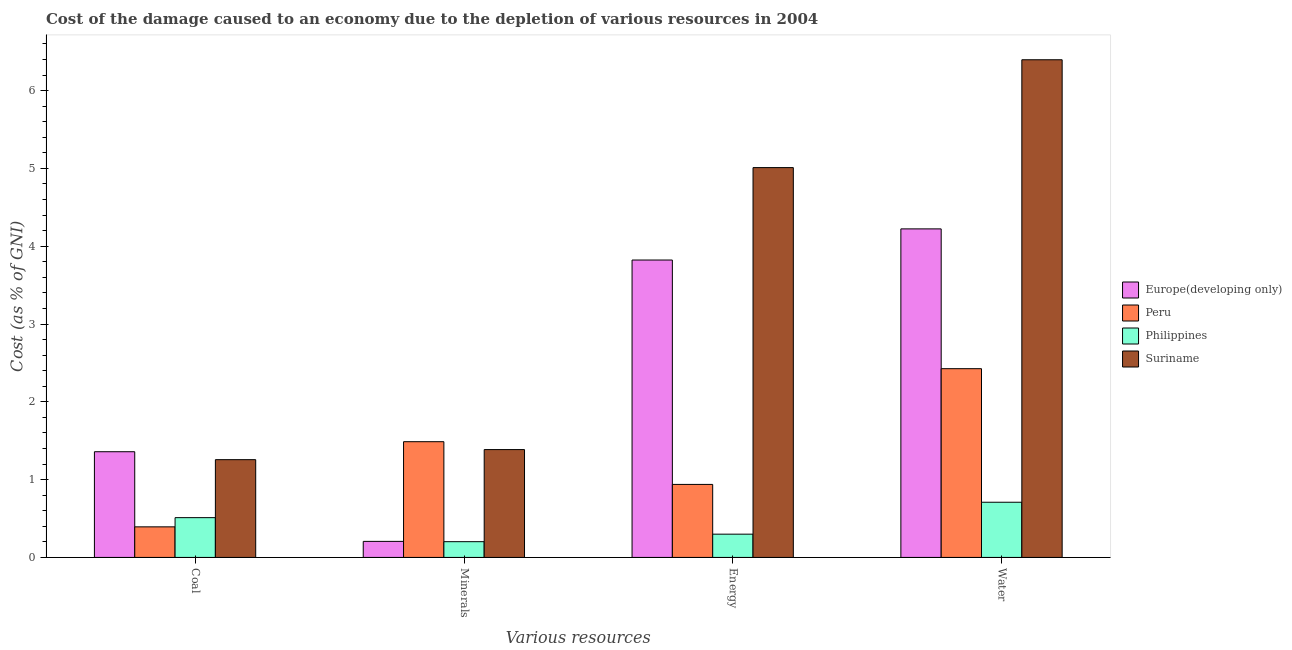How many different coloured bars are there?
Your answer should be compact. 4. How many groups of bars are there?
Provide a succinct answer. 4. Are the number of bars on each tick of the X-axis equal?
Your response must be concise. Yes. How many bars are there on the 3rd tick from the right?
Ensure brevity in your answer.  4. What is the label of the 3rd group of bars from the left?
Your answer should be compact. Energy. What is the cost of damage due to depletion of water in Philippines?
Your response must be concise. 0.71. Across all countries, what is the maximum cost of damage due to depletion of energy?
Keep it short and to the point. 5.01. Across all countries, what is the minimum cost of damage due to depletion of minerals?
Keep it short and to the point. 0.2. In which country was the cost of damage due to depletion of water maximum?
Offer a very short reply. Suriname. In which country was the cost of damage due to depletion of water minimum?
Your answer should be compact. Philippines. What is the total cost of damage due to depletion of water in the graph?
Offer a terse response. 13.75. What is the difference between the cost of damage due to depletion of water in Peru and that in Philippines?
Your answer should be very brief. 1.72. What is the difference between the cost of damage due to depletion of minerals in Philippines and the cost of damage due to depletion of water in Europe(developing only)?
Offer a terse response. -4.02. What is the average cost of damage due to depletion of coal per country?
Make the answer very short. 0.88. What is the difference between the cost of damage due to depletion of energy and cost of damage due to depletion of coal in Europe(developing only)?
Keep it short and to the point. 2.46. What is the ratio of the cost of damage due to depletion of coal in Philippines to that in Peru?
Ensure brevity in your answer.  1.3. Is the cost of damage due to depletion of water in Suriname less than that in Europe(developing only)?
Offer a very short reply. No. What is the difference between the highest and the second highest cost of damage due to depletion of water?
Provide a short and direct response. 2.17. What is the difference between the highest and the lowest cost of damage due to depletion of coal?
Keep it short and to the point. 0.97. In how many countries, is the cost of damage due to depletion of coal greater than the average cost of damage due to depletion of coal taken over all countries?
Your answer should be compact. 2. Is the sum of the cost of damage due to depletion of coal in Suriname and Europe(developing only) greater than the maximum cost of damage due to depletion of water across all countries?
Offer a terse response. No. What does the 1st bar from the left in Minerals represents?
Your answer should be compact. Europe(developing only). Is it the case that in every country, the sum of the cost of damage due to depletion of coal and cost of damage due to depletion of minerals is greater than the cost of damage due to depletion of energy?
Your answer should be compact. No. How many countries are there in the graph?
Keep it short and to the point. 4. What is the difference between two consecutive major ticks on the Y-axis?
Your response must be concise. 1. Are the values on the major ticks of Y-axis written in scientific E-notation?
Provide a succinct answer. No. Does the graph contain any zero values?
Provide a short and direct response. No. Does the graph contain grids?
Ensure brevity in your answer.  No. Where does the legend appear in the graph?
Offer a terse response. Center right. How many legend labels are there?
Your answer should be very brief. 4. How are the legend labels stacked?
Keep it short and to the point. Vertical. What is the title of the graph?
Offer a terse response. Cost of the damage caused to an economy due to the depletion of various resources in 2004 . What is the label or title of the X-axis?
Provide a short and direct response. Various resources. What is the label or title of the Y-axis?
Offer a terse response. Cost (as % of GNI). What is the Cost (as % of GNI) of Europe(developing only) in Coal?
Offer a terse response. 1.36. What is the Cost (as % of GNI) in Peru in Coal?
Offer a terse response. 0.39. What is the Cost (as % of GNI) of Philippines in Coal?
Your answer should be compact. 0.51. What is the Cost (as % of GNI) in Suriname in Coal?
Your answer should be very brief. 1.26. What is the Cost (as % of GNI) in Europe(developing only) in Minerals?
Offer a terse response. 0.21. What is the Cost (as % of GNI) in Peru in Minerals?
Provide a succinct answer. 1.49. What is the Cost (as % of GNI) of Philippines in Minerals?
Keep it short and to the point. 0.2. What is the Cost (as % of GNI) in Suriname in Minerals?
Make the answer very short. 1.39. What is the Cost (as % of GNI) in Europe(developing only) in Energy?
Provide a short and direct response. 3.82. What is the Cost (as % of GNI) in Peru in Energy?
Provide a succinct answer. 0.94. What is the Cost (as % of GNI) of Philippines in Energy?
Keep it short and to the point. 0.3. What is the Cost (as % of GNI) of Suriname in Energy?
Offer a very short reply. 5.01. What is the Cost (as % of GNI) in Europe(developing only) in Water?
Provide a short and direct response. 4.22. What is the Cost (as % of GNI) of Peru in Water?
Make the answer very short. 2.43. What is the Cost (as % of GNI) of Philippines in Water?
Provide a succinct answer. 0.71. What is the Cost (as % of GNI) of Suriname in Water?
Provide a succinct answer. 6.4. Across all Various resources, what is the maximum Cost (as % of GNI) in Europe(developing only)?
Offer a terse response. 4.22. Across all Various resources, what is the maximum Cost (as % of GNI) of Peru?
Your answer should be very brief. 2.43. Across all Various resources, what is the maximum Cost (as % of GNI) of Philippines?
Your response must be concise. 0.71. Across all Various resources, what is the maximum Cost (as % of GNI) in Suriname?
Ensure brevity in your answer.  6.4. Across all Various resources, what is the minimum Cost (as % of GNI) of Europe(developing only)?
Provide a short and direct response. 0.21. Across all Various resources, what is the minimum Cost (as % of GNI) in Peru?
Your answer should be compact. 0.39. Across all Various resources, what is the minimum Cost (as % of GNI) of Philippines?
Offer a very short reply. 0.2. Across all Various resources, what is the minimum Cost (as % of GNI) in Suriname?
Keep it short and to the point. 1.26. What is the total Cost (as % of GNI) of Europe(developing only) in the graph?
Your response must be concise. 9.61. What is the total Cost (as % of GNI) of Peru in the graph?
Give a very brief answer. 5.24. What is the total Cost (as % of GNI) of Philippines in the graph?
Offer a terse response. 1.72. What is the total Cost (as % of GNI) of Suriname in the graph?
Ensure brevity in your answer.  14.05. What is the difference between the Cost (as % of GNI) in Europe(developing only) in Coal and that in Minerals?
Give a very brief answer. 1.15. What is the difference between the Cost (as % of GNI) of Peru in Coal and that in Minerals?
Provide a short and direct response. -1.09. What is the difference between the Cost (as % of GNI) of Philippines in Coal and that in Minerals?
Provide a succinct answer. 0.31. What is the difference between the Cost (as % of GNI) of Suriname in Coal and that in Minerals?
Give a very brief answer. -0.13. What is the difference between the Cost (as % of GNI) of Europe(developing only) in Coal and that in Energy?
Offer a terse response. -2.46. What is the difference between the Cost (as % of GNI) of Peru in Coal and that in Energy?
Give a very brief answer. -0.55. What is the difference between the Cost (as % of GNI) in Philippines in Coal and that in Energy?
Keep it short and to the point. 0.21. What is the difference between the Cost (as % of GNI) in Suriname in Coal and that in Energy?
Offer a terse response. -3.75. What is the difference between the Cost (as % of GNI) of Europe(developing only) in Coal and that in Water?
Your answer should be very brief. -2.86. What is the difference between the Cost (as % of GNI) in Peru in Coal and that in Water?
Offer a very short reply. -2.03. What is the difference between the Cost (as % of GNI) of Philippines in Coal and that in Water?
Your response must be concise. -0.2. What is the difference between the Cost (as % of GNI) in Suriname in Coal and that in Water?
Your response must be concise. -5.14. What is the difference between the Cost (as % of GNI) in Europe(developing only) in Minerals and that in Energy?
Ensure brevity in your answer.  -3.62. What is the difference between the Cost (as % of GNI) in Peru in Minerals and that in Energy?
Give a very brief answer. 0.55. What is the difference between the Cost (as % of GNI) of Philippines in Minerals and that in Energy?
Offer a terse response. -0.1. What is the difference between the Cost (as % of GNI) of Suriname in Minerals and that in Energy?
Your response must be concise. -3.62. What is the difference between the Cost (as % of GNI) in Europe(developing only) in Minerals and that in Water?
Your answer should be compact. -4.02. What is the difference between the Cost (as % of GNI) of Peru in Minerals and that in Water?
Ensure brevity in your answer.  -0.94. What is the difference between the Cost (as % of GNI) of Philippines in Minerals and that in Water?
Offer a terse response. -0.51. What is the difference between the Cost (as % of GNI) in Suriname in Minerals and that in Water?
Keep it short and to the point. -5.01. What is the difference between the Cost (as % of GNI) of Europe(developing only) in Energy and that in Water?
Offer a terse response. -0.4. What is the difference between the Cost (as % of GNI) in Peru in Energy and that in Water?
Make the answer very short. -1.49. What is the difference between the Cost (as % of GNI) in Philippines in Energy and that in Water?
Give a very brief answer. -0.41. What is the difference between the Cost (as % of GNI) in Suriname in Energy and that in Water?
Make the answer very short. -1.39. What is the difference between the Cost (as % of GNI) in Europe(developing only) in Coal and the Cost (as % of GNI) in Peru in Minerals?
Make the answer very short. -0.13. What is the difference between the Cost (as % of GNI) of Europe(developing only) in Coal and the Cost (as % of GNI) of Philippines in Minerals?
Provide a short and direct response. 1.16. What is the difference between the Cost (as % of GNI) in Europe(developing only) in Coal and the Cost (as % of GNI) in Suriname in Minerals?
Make the answer very short. -0.03. What is the difference between the Cost (as % of GNI) of Peru in Coal and the Cost (as % of GNI) of Philippines in Minerals?
Give a very brief answer. 0.19. What is the difference between the Cost (as % of GNI) of Peru in Coal and the Cost (as % of GNI) of Suriname in Minerals?
Your answer should be very brief. -0.99. What is the difference between the Cost (as % of GNI) in Philippines in Coal and the Cost (as % of GNI) in Suriname in Minerals?
Make the answer very short. -0.87. What is the difference between the Cost (as % of GNI) in Europe(developing only) in Coal and the Cost (as % of GNI) in Peru in Energy?
Your response must be concise. 0.42. What is the difference between the Cost (as % of GNI) of Europe(developing only) in Coal and the Cost (as % of GNI) of Philippines in Energy?
Your answer should be compact. 1.06. What is the difference between the Cost (as % of GNI) in Europe(developing only) in Coal and the Cost (as % of GNI) in Suriname in Energy?
Your response must be concise. -3.65. What is the difference between the Cost (as % of GNI) of Peru in Coal and the Cost (as % of GNI) of Philippines in Energy?
Ensure brevity in your answer.  0.09. What is the difference between the Cost (as % of GNI) of Peru in Coal and the Cost (as % of GNI) of Suriname in Energy?
Provide a short and direct response. -4.62. What is the difference between the Cost (as % of GNI) in Philippines in Coal and the Cost (as % of GNI) in Suriname in Energy?
Offer a very short reply. -4.5. What is the difference between the Cost (as % of GNI) of Europe(developing only) in Coal and the Cost (as % of GNI) of Peru in Water?
Ensure brevity in your answer.  -1.07. What is the difference between the Cost (as % of GNI) of Europe(developing only) in Coal and the Cost (as % of GNI) of Philippines in Water?
Your answer should be compact. 0.65. What is the difference between the Cost (as % of GNI) in Europe(developing only) in Coal and the Cost (as % of GNI) in Suriname in Water?
Offer a very short reply. -5.04. What is the difference between the Cost (as % of GNI) of Peru in Coal and the Cost (as % of GNI) of Philippines in Water?
Offer a terse response. -0.32. What is the difference between the Cost (as % of GNI) in Peru in Coal and the Cost (as % of GNI) in Suriname in Water?
Provide a short and direct response. -6. What is the difference between the Cost (as % of GNI) in Philippines in Coal and the Cost (as % of GNI) in Suriname in Water?
Your response must be concise. -5.88. What is the difference between the Cost (as % of GNI) of Europe(developing only) in Minerals and the Cost (as % of GNI) of Peru in Energy?
Ensure brevity in your answer.  -0.73. What is the difference between the Cost (as % of GNI) of Europe(developing only) in Minerals and the Cost (as % of GNI) of Philippines in Energy?
Make the answer very short. -0.09. What is the difference between the Cost (as % of GNI) in Europe(developing only) in Minerals and the Cost (as % of GNI) in Suriname in Energy?
Offer a very short reply. -4.8. What is the difference between the Cost (as % of GNI) of Peru in Minerals and the Cost (as % of GNI) of Philippines in Energy?
Provide a succinct answer. 1.19. What is the difference between the Cost (as % of GNI) of Peru in Minerals and the Cost (as % of GNI) of Suriname in Energy?
Ensure brevity in your answer.  -3.52. What is the difference between the Cost (as % of GNI) in Philippines in Minerals and the Cost (as % of GNI) in Suriname in Energy?
Ensure brevity in your answer.  -4.81. What is the difference between the Cost (as % of GNI) of Europe(developing only) in Minerals and the Cost (as % of GNI) of Peru in Water?
Your answer should be compact. -2.22. What is the difference between the Cost (as % of GNI) in Europe(developing only) in Minerals and the Cost (as % of GNI) in Philippines in Water?
Make the answer very short. -0.5. What is the difference between the Cost (as % of GNI) in Europe(developing only) in Minerals and the Cost (as % of GNI) in Suriname in Water?
Give a very brief answer. -6.19. What is the difference between the Cost (as % of GNI) in Peru in Minerals and the Cost (as % of GNI) in Philippines in Water?
Offer a very short reply. 0.78. What is the difference between the Cost (as % of GNI) of Peru in Minerals and the Cost (as % of GNI) of Suriname in Water?
Offer a terse response. -4.91. What is the difference between the Cost (as % of GNI) in Philippines in Minerals and the Cost (as % of GNI) in Suriname in Water?
Give a very brief answer. -6.19. What is the difference between the Cost (as % of GNI) of Europe(developing only) in Energy and the Cost (as % of GNI) of Peru in Water?
Offer a very short reply. 1.4. What is the difference between the Cost (as % of GNI) in Europe(developing only) in Energy and the Cost (as % of GNI) in Philippines in Water?
Offer a terse response. 3.11. What is the difference between the Cost (as % of GNI) in Europe(developing only) in Energy and the Cost (as % of GNI) in Suriname in Water?
Your response must be concise. -2.57. What is the difference between the Cost (as % of GNI) of Peru in Energy and the Cost (as % of GNI) of Philippines in Water?
Give a very brief answer. 0.23. What is the difference between the Cost (as % of GNI) of Peru in Energy and the Cost (as % of GNI) of Suriname in Water?
Make the answer very short. -5.46. What is the difference between the Cost (as % of GNI) of Philippines in Energy and the Cost (as % of GNI) of Suriname in Water?
Offer a very short reply. -6.1. What is the average Cost (as % of GNI) of Europe(developing only) per Various resources?
Offer a very short reply. 2.4. What is the average Cost (as % of GNI) in Peru per Various resources?
Your answer should be very brief. 1.31. What is the average Cost (as % of GNI) in Philippines per Various resources?
Ensure brevity in your answer.  0.43. What is the average Cost (as % of GNI) in Suriname per Various resources?
Provide a succinct answer. 3.51. What is the difference between the Cost (as % of GNI) of Europe(developing only) and Cost (as % of GNI) of Peru in Coal?
Give a very brief answer. 0.97. What is the difference between the Cost (as % of GNI) of Europe(developing only) and Cost (as % of GNI) of Philippines in Coal?
Offer a terse response. 0.85. What is the difference between the Cost (as % of GNI) in Europe(developing only) and Cost (as % of GNI) in Suriname in Coal?
Keep it short and to the point. 0.1. What is the difference between the Cost (as % of GNI) in Peru and Cost (as % of GNI) in Philippines in Coal?
Give a very brief answer. -0.12. What is the difference between the Cost (as % of GNI) of Peru and Cost (as % of GNI) of Suriname in Coal?
Keep it short and to the point. -0.86. What is the difference between the Cost (as % of GNI) of Philippines and Cost (as % of GNI) of Suriname in Coal?
Keep it short and to the point. -0.75. What is the difference between the Cost (as % of GNI) of Europe(developing only) and Cost (as % of GNI) of Peru in Minerals?
Offer a very short reply. -1.28. What is the difference between the Cost (as % of GNI) in Europe(developing only) and Cost (as % of GNI) in Philippines in Minerals?
Your response must be concise. 0. What is the difference between the Cost (as % of GNI) of Europe(developing only) and Cost (as % of GNI) of Suriname in Minerals?
Offer a very short reply. -1.18. What is the difference between the Cost (as % of GNI) in Peru and Cost (as % of GNI) in Philippines in Minerals?
Your response must be concise. 1.28. What is the difference between the Cost (as % of GNI) in Peru and Cost (as % of GNI) in Suriname in Minerals?
Offer a very short reply. 0.1. What is the difference between the Cost (as % of GNI) of Philippines and Cost (as % of GNI) of Suriname in Minerals?
Make the answer very short. -1.18. What is the difference between the Cost (as % of GNI) of Europe(developing only) and Cost (as % of GNI) of Peru in Energy?
Your response must be concise. 2.88. What is the difference between the Cost (as % of GNI) of Europe(developing only) and Cost (as % of GNI) of Philippines in Energy?
Offer a terse response. 3.52. What is the difference between the Cost (as % of GNI) of Europe(developing only) and Cost (as % of GNI) of Suriname in Energy?
Provide a short and direct response. -1.19. What is the difference between the Cost (as % of GNI) of Peru and Cost (as % of GNI) of Philippines in Energy?
Your response must be concise. 0.64. What is the difference between the Cost (as % of GNI) in Peru and Cost (as % of GNI) in Suriname in Energy?
Your answer should be very brief. -4.07. What is the difference between the Cost (as % of GNI) of Philippines and Cost (as % of GNI) of Suriname in Energy?
Keep it short and to the point. -4.71. What is the difference between the Cost (as % of GNI) in Europe(developing only) and Cost (as % of GNI) in Peru in Water?
Offer a very short reply. 1.8. What is the difference between the Cost (as % of GNI) in Europe(developing only) and Cost (as % of GNI) in Philippines in Water?
Offer a very short reply. 3.51. What is the difference between the Cost (as % of GNI) of Europe(developing only) and Cost (as % of GNI) of Suriname in Water?
Provide a succinct answer. -2.17. What is the difference between the Cost (as % of GNI) in Peru and Cost (as % of GNI) in Philippines in Water?
Your answer should be compact. 1.72. What is the difference between the Cost (as % of GNI) in Peru and Cost (as % of GNI) in Suriname in Water?
Provide a short and direct response. -3.97. What is the difference between the Cost (as % of GNI) in Philippines and Cost (as % of GNI) in Suriname in Water?
Offer a very short reply. -5.69. What is the ratio of the Cost (as % of GNI) in Europe(developing only) in Coal to that in Minerals?
Keep it short and to the point. 6.59. What is the ratio of the Cost (as % of GNI) of Peru in Coal to that in Minerals?
Ensure brevity in your answer.  0.26. What is the ratio of the Cost (as % of GNI) of Philippines in Coal to that in Minerals?
Ensure brevity in your answer.  2.53. What is the ratio of the Cost (as % of GNI) of Suriname in Coal to that in Minerals?
Your answer should be very brief. 0.91. What is the ratio of the Cost (as % of GNI) of Europe(developing only) in Coal to that in Energy?
Your answer should be compact. 0.36. What is the ratio of the Cost (as % of GNI) of Peru in Coal to that in Energy?
Your response must be concise. 0.42. What is the ratio of the Cost (as % of GNI) of Philippines in Coal to that in Energy?
Provide a succinct answer. 1.71. What is the ratio of the Cost (as % of GNI) in Suriname in Coal to that in Energy?
Provide a succinct answer. 0.25. What is the ratio of the Cost (as % of GNI) in Europe(developing only) in Coal to that in Water?
Your answer should be compact. 0.32. What is the ratio of the Cost (as % of GNI) of Peru in Coal to that in Water?
Your answer should be compact. 0.16. What is the ratio of the Cost (as % of GNI) of Philippines in Coal to that in Water?
Keep it short and to the point. 0.72. What is the ratio of the Cost (as % of GNI) in Suriname in Coal to that in Water?
Provide a short and direct response. 0.2. What is the ratio of the Cost (as % of GNI) of Europe(developing only) in Minerals to that in Energy?
Provide a succinct answer. 0.05. What is the ratio of the Cost (as % of GNI) of Peru in Minerals to that in Energy?
Your answer should be very brief. 1.59. What is the ratio of the Cost (as % of GNI) in Philippines in Minerals to that in Energy?
Your answer should be very brief. 0.68. What is the ratio of the Cost (as % of GNI) in Suriname in Minerals to that in Energy?
Offer a terse response. 0.28. What is the ratio of the Cost (as % of GNI) of Europe(developing only) in Minerals to that in Water?
Make the answer very short. 0.05. What is the ratio of the Cost (as % of GNI) of Peru in Minerals to that in Water?
Keep it short and to the point. 0.61. What is the ratio of the Cost (as % of GNI) in Philippines in Minerals to that in Water?
Offer a very short reply. 0.29. What is the ratio of the Cost (as % of GNI) of Suriname in Minerals to that in Water?
Your answer should be very brief. 0.22. What is the ratio of the Cost (as % of GNI) of Europe(developing only) in Energy to that in Water?
Your answer should be very brief. 0.91. What is the ratio of the Cost (as % of GNI) of Peru in Energy to that in Water?
Provide a succinct answer. 0.39. What is the ratio of the Cost (as % of GNI) in Philippines in Energy to that in Water?
Your answer should be very brief. 0.42. What is the ratio of the Cost (as % of GNI) in Suriname in Energy to that in Water?
Make the answer very short. 0.78. What is the difference between the highest and the second highest Cost (as % of GNI) of Europe(developing only)?
Your answer should be compact. 0.4. What is the difference between the highest and the second highest Cost (as % of GNI) of Peru?
Your response must be concise. 0.94. What is the difference between the highest and the second highest Cost (as % of GNI) of Philippines?
Keep it short and to the point. 0.2. What is the difference between the highest and the second highest Cost (as % of GNI) in Suriname?
Keep it short and to the point. 1.39. What is the difference between the highest and the lowest Cost (as % of GNI) of Europe(developing only)?
Your response must be concise. 4.02. What is the difference between the highest and the lowest Cost (as % of GNI) in Peru?
Provide a short and direct response. 2.03. What is the difference between the highest and the lowest Cost (as % of GNI) in Philippines?
Give a very brief answer. 0.51. What is the difference between the highest and the lowest Cost (as % of GNI) in Suriname?
Offer a very short reply. 5.14. 